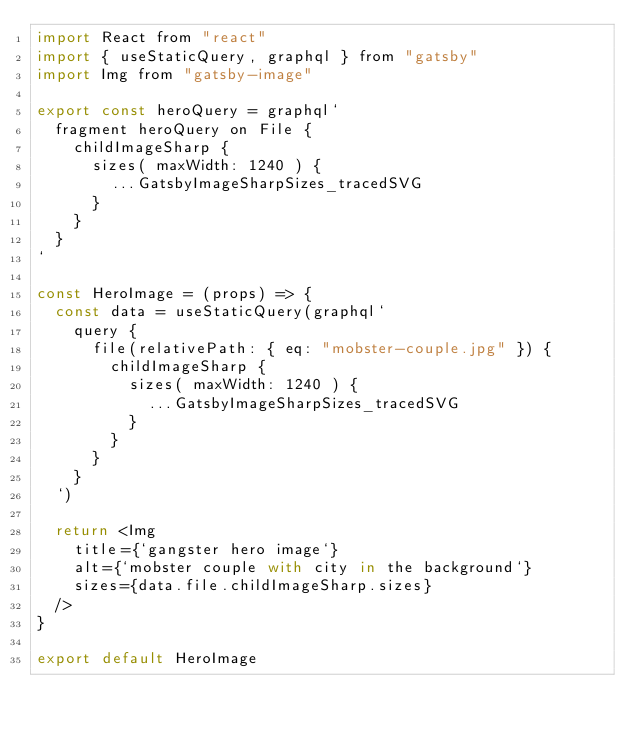<code> <loc_0><loc_0><loc_500><loc_500><_JavaScript_>import React from "react"
import { useStaticQuery, graphql } from "gatsby"
import Img from "gatsby-image"

export const heroQuery = graphql`
  fragment heroQuery on File {
    childImageSharp {
      sizes( maxWidth: 1240 ) {
        ...GatsbyImageSharpSizes_tracedSVG
      }
    }
  }
`

const HeroImage = (props) => {
  const data = useStaticQuery(graphql`
    query {
      file(relativePath: { eq: "mobster-couple.jpg" }) {
        childImageSharp {
          sizes( maxWidth: 1240 ) {
            ...GatsbyImageSharpSizes_tracedSVG
          }
        }
      }
    }
  `)

  return <Img 
    title={`gangster hero image`}
    alt={`mobster couple with city in the background`}
    sizes={data.file.childImageSharp.sizes}
  />
}

export default HeroImage
</code> 